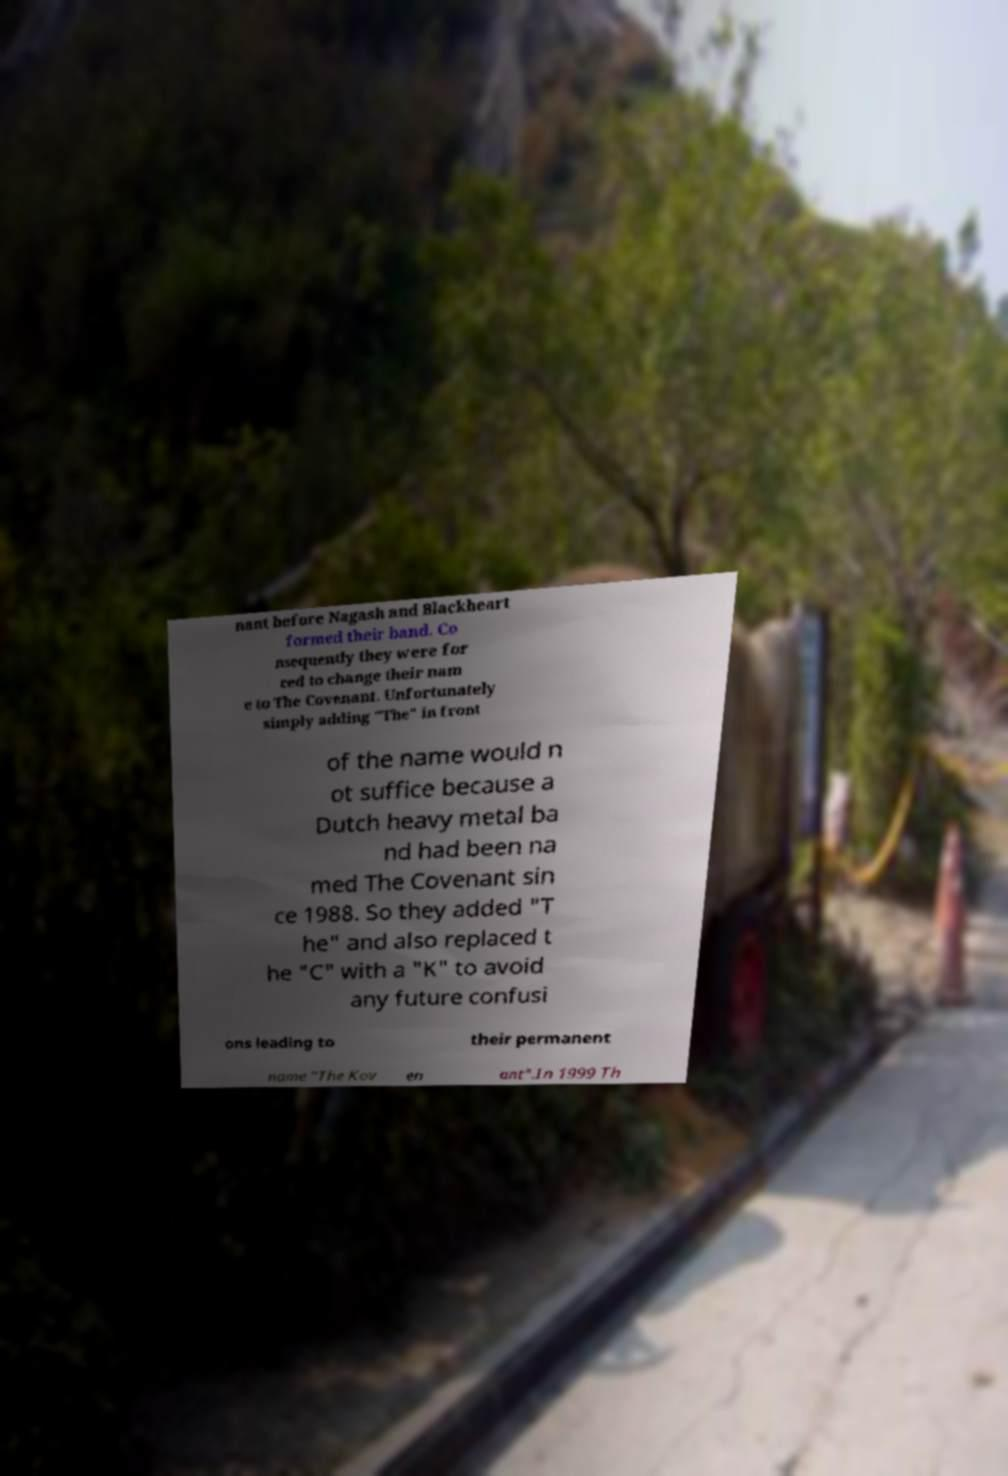For documentation purposes, I need the text within this image transcribed. Could you provide that? nant before Nagash and Blackheart formed their band. Co nsequently they were for ced to change their nam e to The Covenant. Unfortunately simply adding "The" in front of the name would n ot suffice because a Dutch heavy metal ba nd had been na med The Covenant sin ce 1988. So they added "T he" and also replaced t he "C" with a "K" to avoid any future confusi ons leading to their permanent name "The Kov en ant".In 1999 Th 